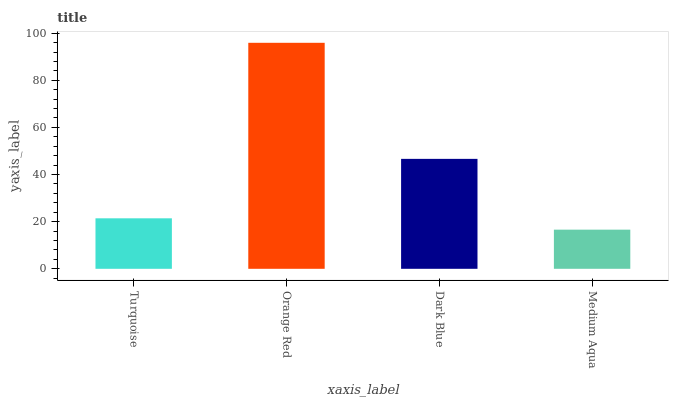Is Medium Aqua the minimum?
Answer yes or no. Yes. Is Orange Red the maximum?
Answer yes or no. Yes. Is Dark Blue the minimum?
Answer yes or no. No. Is Dark Blue the maximum?
Answer yes or no. No. Is Orange Red greater than Dark Blue?
Answer yes or no. Yes. Is Dark Blue less than Orange Red?
Answer yes or no. Yes. Is Dark Blue greater than Orange Red?
Answer yes or no. No. Is Orange Red less than Dark Blue?
Answer yes or no. No. Is Dark Blue the high median?
Answer yes or no. Yes. Is Turquoise the low median?
Answer yes or no. Yes. Is Orange Red the high median?
Answer yes or no. No. Is Orange Red the low median?
Answer yes or no. No. 